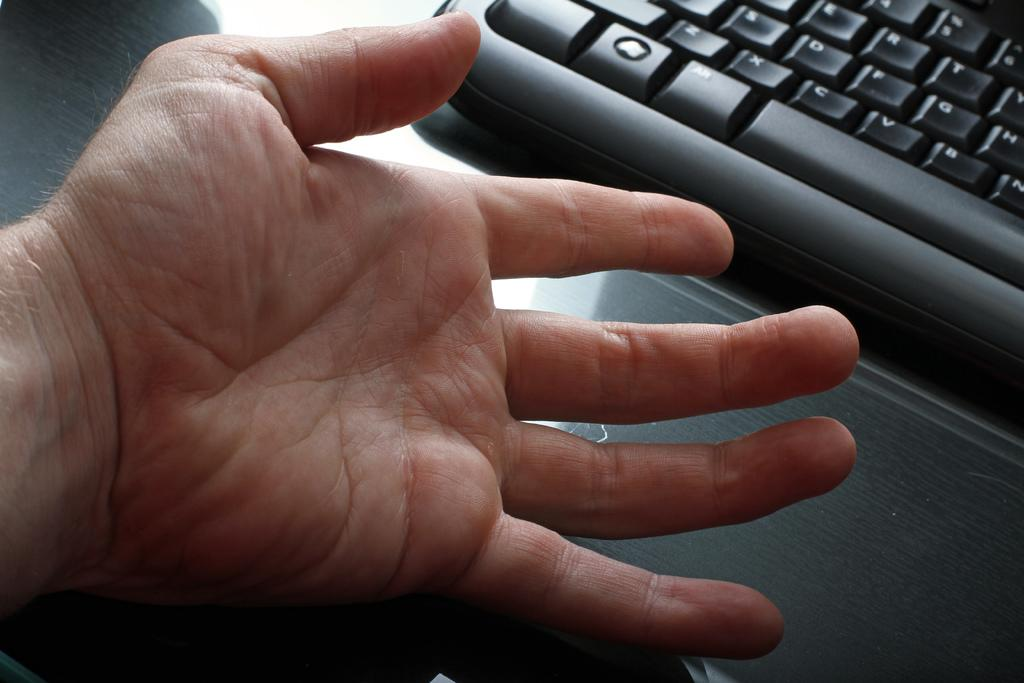<image>
Create a compact narrative representing the image presented. The black keyboard has the c key next to the v key 